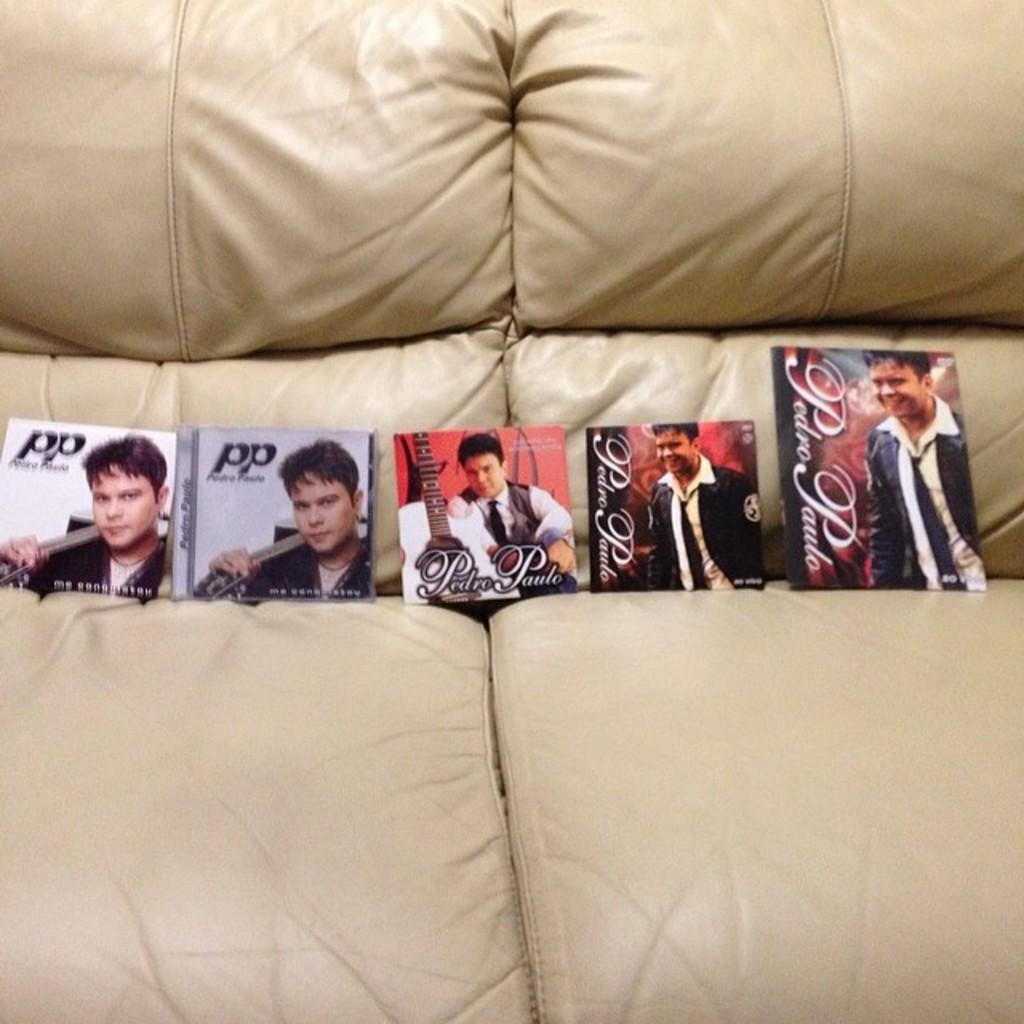In one or two sentences, can you explain what this image depicts? In the picture we can see some photos which are on the cream color couch. 